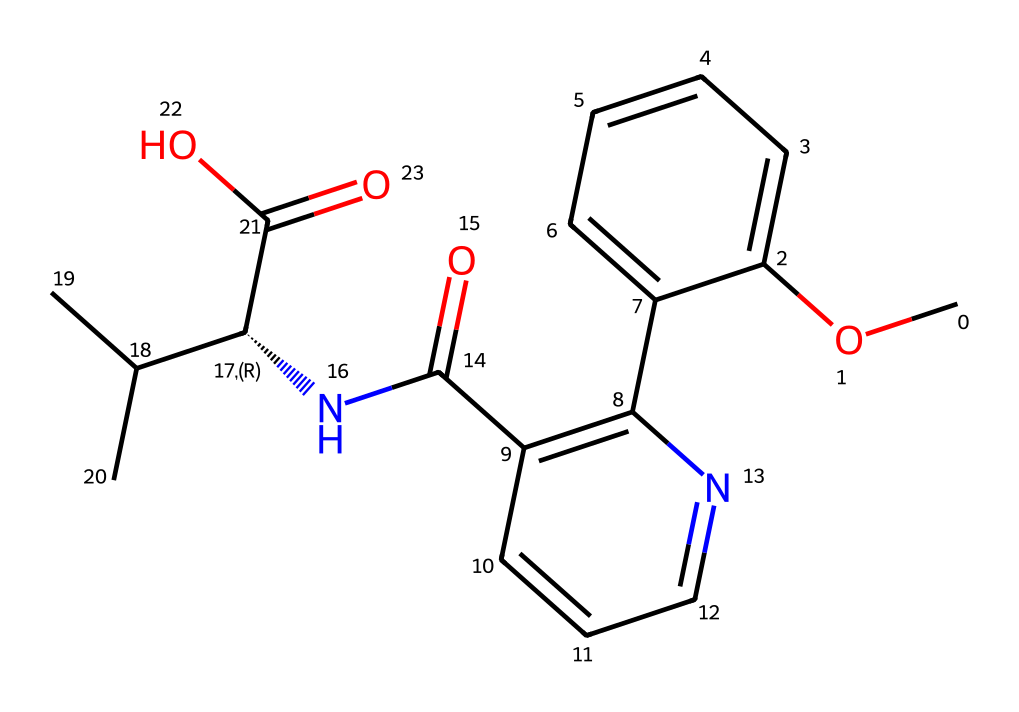how many carbon atoms are in the chemical? To determine the number of carbon atoms, we can analyze the SMILES representation. Count each 'C' in the structure, including those in branches and rings, to find the total quantity. The total count is found to be 16.
Answer: 16 what is the chemical's molecular weight? The molecular weight can be calculated from the SMILES by adding up the atomic weights of each atom in the structure. Carbon (C): 12.01 g/mol, Oxygen (O): 16.00 g/mol, Nitrogen (N): 14.01 g/mol, and Hydrogen (H): 1.008 g/mol. Calculating the total gives a molecular weight of approximately 278.36 g/mol.
Answer: 278.36 g/mol what functional groups are present in this compound? Analyzing the structure shows multiple functional groups: a hydroxyl group (-OH) attached to a carbon, an amine (the nitrogen in the structure), and a carbonyl group (C=O). These are characteristic of the structure, indicating it contains alcohol, amine, and ketone functional groups.
Answer: alcohol, amine, ketone what kind of rings are present in the structure? Looking closely at the chemical structure, we can identify aromatic rings and a non-aromatic cyclic structure. The presence of alternating double bonds within the carbon atoms indicates aromaticity in at least one of the rings.
Answer: aromatic and non-aromatic what is the significance of the nitrogen atom in this antibiotic? The nitrogen atom typically indicates the presence of a basic site in the molecule, often important for binding to bacterial targets. In this structure, the nitrogen is part of an amine, contributing to the drug's mechanism of action against infections.
Answer: basic site, amine 